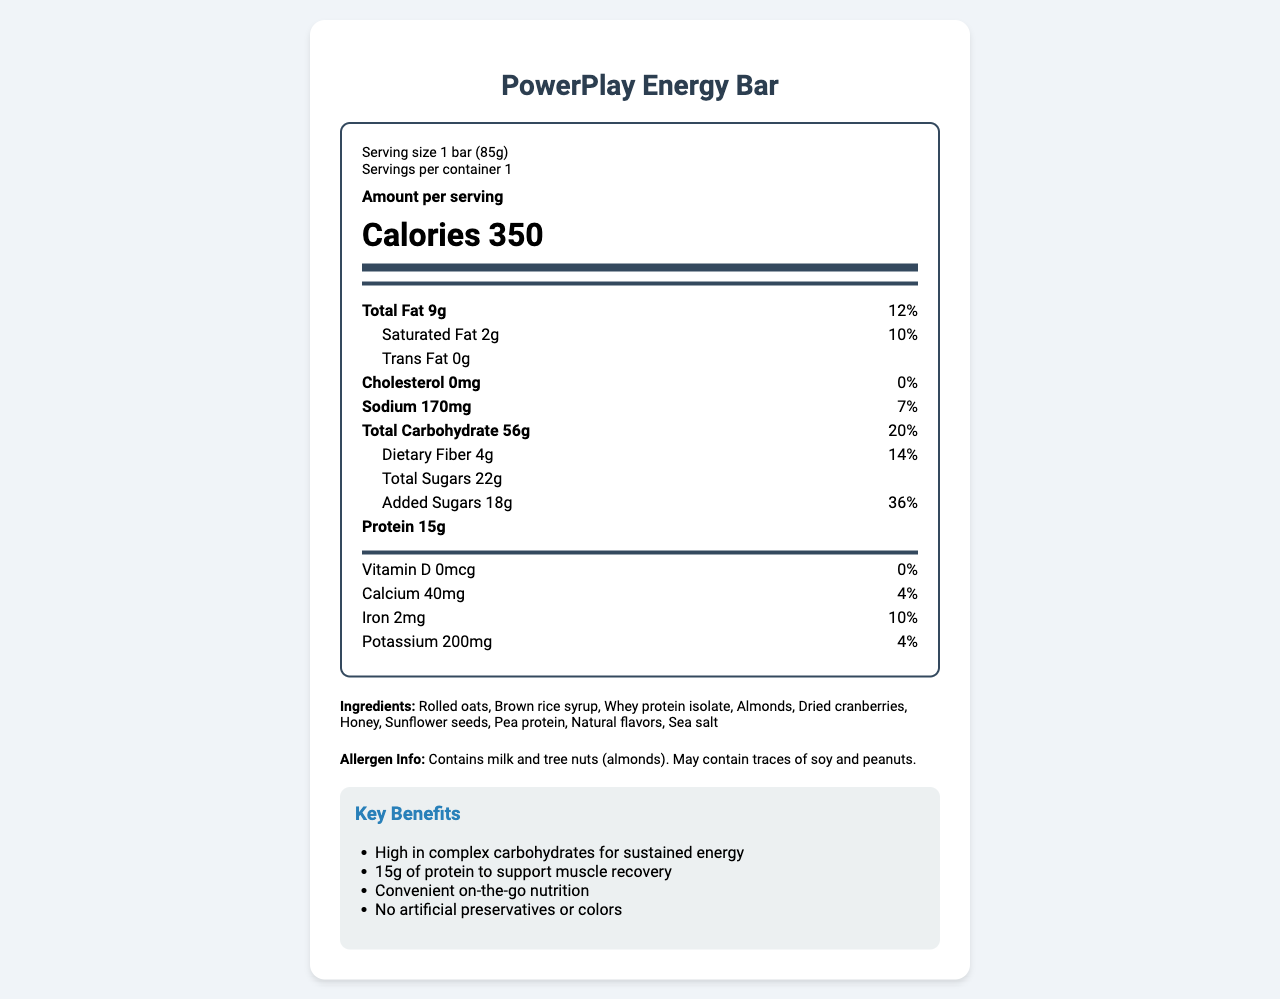what is the product name? The name of the product is clearly stated at the top of the document.
Answer: PowerPlay Energy Bar what is the serving size of the PowerPlay Energy Bar? The serving size is listed in the serving info section of the nutrition label.
Answer: 1 bar (85g) how many grams of total carbohydrate does the bar contain? The total carbohydrate content is listed in the daily value section of the nutrition label.
Answer: 56g what percentage of the daily value does the dietary fiber provide? The daily value percentage for dietary fiber is listed next to its gram amount in the daily value section of the nutrition label.
Answer: 14% does this product contain any trans fat? The amount of trans fat is listed as 0g in the daily value section of the nutrition label.
Answer: No what are the main ingredients in the PowerPlay Energy Bar? A. Almonds, honey, rolled oats B. Whey protein isolate, brown rice syrup, dried cranberries C. Sea salt, sunflower seeds, natural flavors The ingredient list shows that the main ingredients are rolled oats, brown rice syrup, whey protein isolate, almonds, dried cranberries, honey, sunflower seeds, pea protein, natural flavors, and sea salt.
Answer: B what certifications does this product have? A. USDA Organic, Gluten-Free B. NSF Certified for Sport, Non-GMO Project Verified C. Fair Trade Certified, Vegan At the bottom of the document, it states that the product is NSF Certified for Sport and Non-GMO Project Verified.
Answer: B is the PowerPlay Energy Bar suitable for someone who has a peanut allergy? The allergen info states that the product contains milk and tree nuts (almonds) and may contain traces of soy and peanuts, making it unsuitable for someone with a peanut allergy.
Answer: No summarize the key benefits of the PowerPlay Energy Bar. The summary of the key benefits can be found in the features section of the document that highlights what makes the product beneficial.
Answer: The PowerPlay Energy Bar is high in complex carbohydrates for sustained energy, contains 15g of protein to support muscle recovery, offers convenient on-the-go nutrition, and has no artificial preservatives or colors. how much cholesterol is in the bar? The amount of cholesterol is listed in the daily value section as 0mg.
Answer: 0mg who is the intended target audience for the PowerPlay Energy Bar? The target audience is mentioned in the product description section of the document.
Answer: Student-athletes, particularly basketball players how should the PowerPlay Energy Bar be stored? The storage instructions specify how to store the bar and the time frame for consumption after opening.
Answer: Store in a cool, dry place. Consume within 7 days of opening. what is the price of the PowerPlay Energy Bar? There is no information provided in the document about the price of the PowerPlay Energy Bar.
Answer: Not enough information 